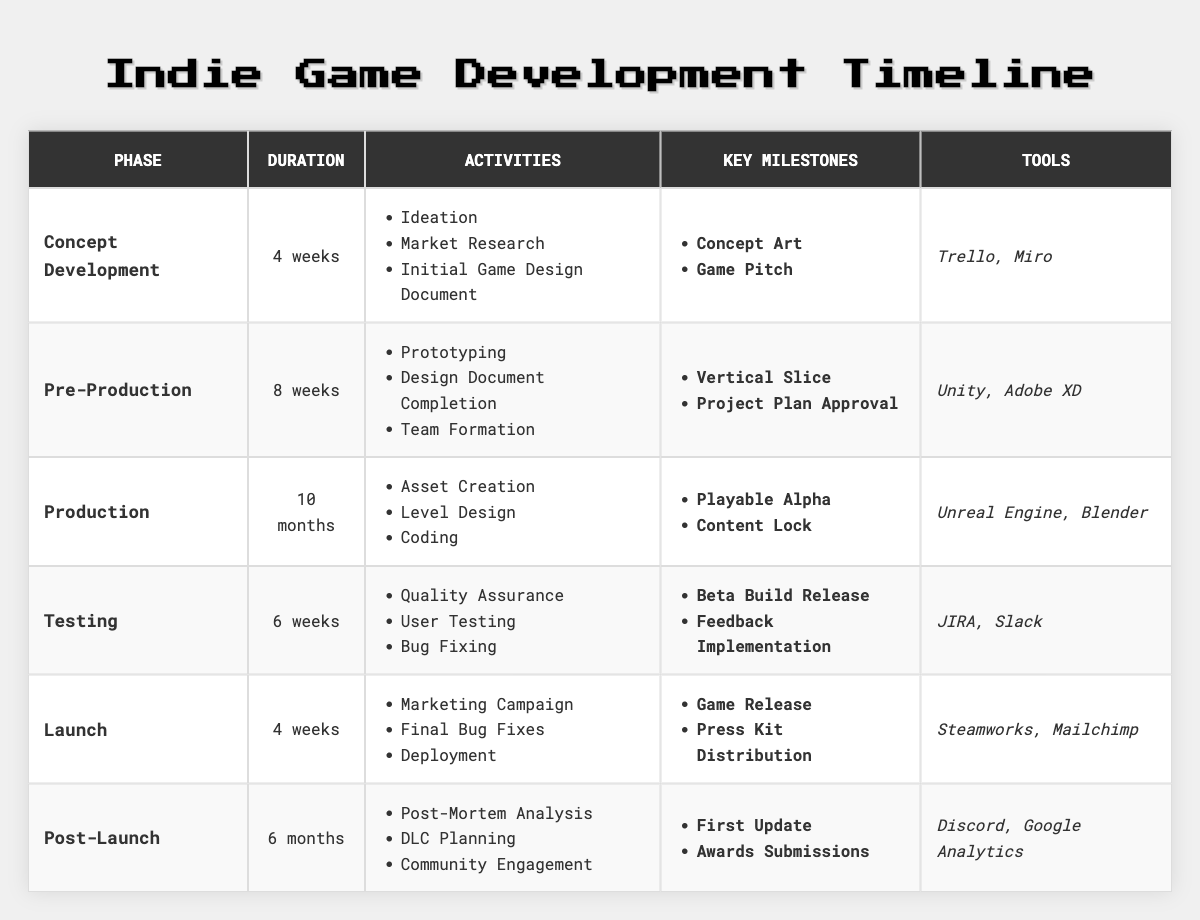What is the duration of the Production phase? According to the table, the Production phase has a duration of 10 months listed in the corresponding cell of the Duration column.
Answer: 10 months Which phase has the longest duration? By examining the Duration column, the Production phase has the longest duration of 10 months compared to the other phases, which are measured in weeks.
Answer: Production How many weeks are allocated to the Testing phase? The table shows that the Testing phase has a duration of 6 weeks as specified in the Duration column.
Answer: 6 weeks Do all phases include a milestone related to community engagement? The table indicates that only the Post-Launch phase includes activities related to community engagement, while the other phases do not mention it in their milestones.
Answer: No What tool is used during the Pre-Production phase? Looking at the Tools column corresponding to the Pre-Production phase, it lists Unity and Adobe XD as the tools used in this phase.
Answer: Unity, Adobe XD What is the total duration in weeks for the Concept Development and Launch phases combined? The Concept Development phase lasts 4 weeks, and the Launch phase lasts 4 weeks. Adding these together gives 4 + 4 = 8 weeks as the total duration.
Answer: 8 weeks Is "Initial Game Design Document" an activity in the Launch phase? The activities listed under the Launch phase do not include "Initial Game Design Document," but rather focus on marketing and final preparations.
Answer: No What are the key milestones for the Post-Launch phase? The table lists the milestones for the Post-Launch phase as "First Update" and "Awards Submissions," which can be found under the corresponding column.
Answer: First Update, Awards Submissions How many activities are listed for the Production phase? The Production phase contains three activities: Asset Creation, Level Design, and Coding, as stated in the Activities column.
Answer: 3 activities What is the duration difference between the Pre-Production and Testing phases? The Pre-Production phase lasts 8 weeks, while the Testing phase lasts 6 weeks. Thus, the duration difference is 8 - 6 = 2 weeks.
Answer: 2 weeks 